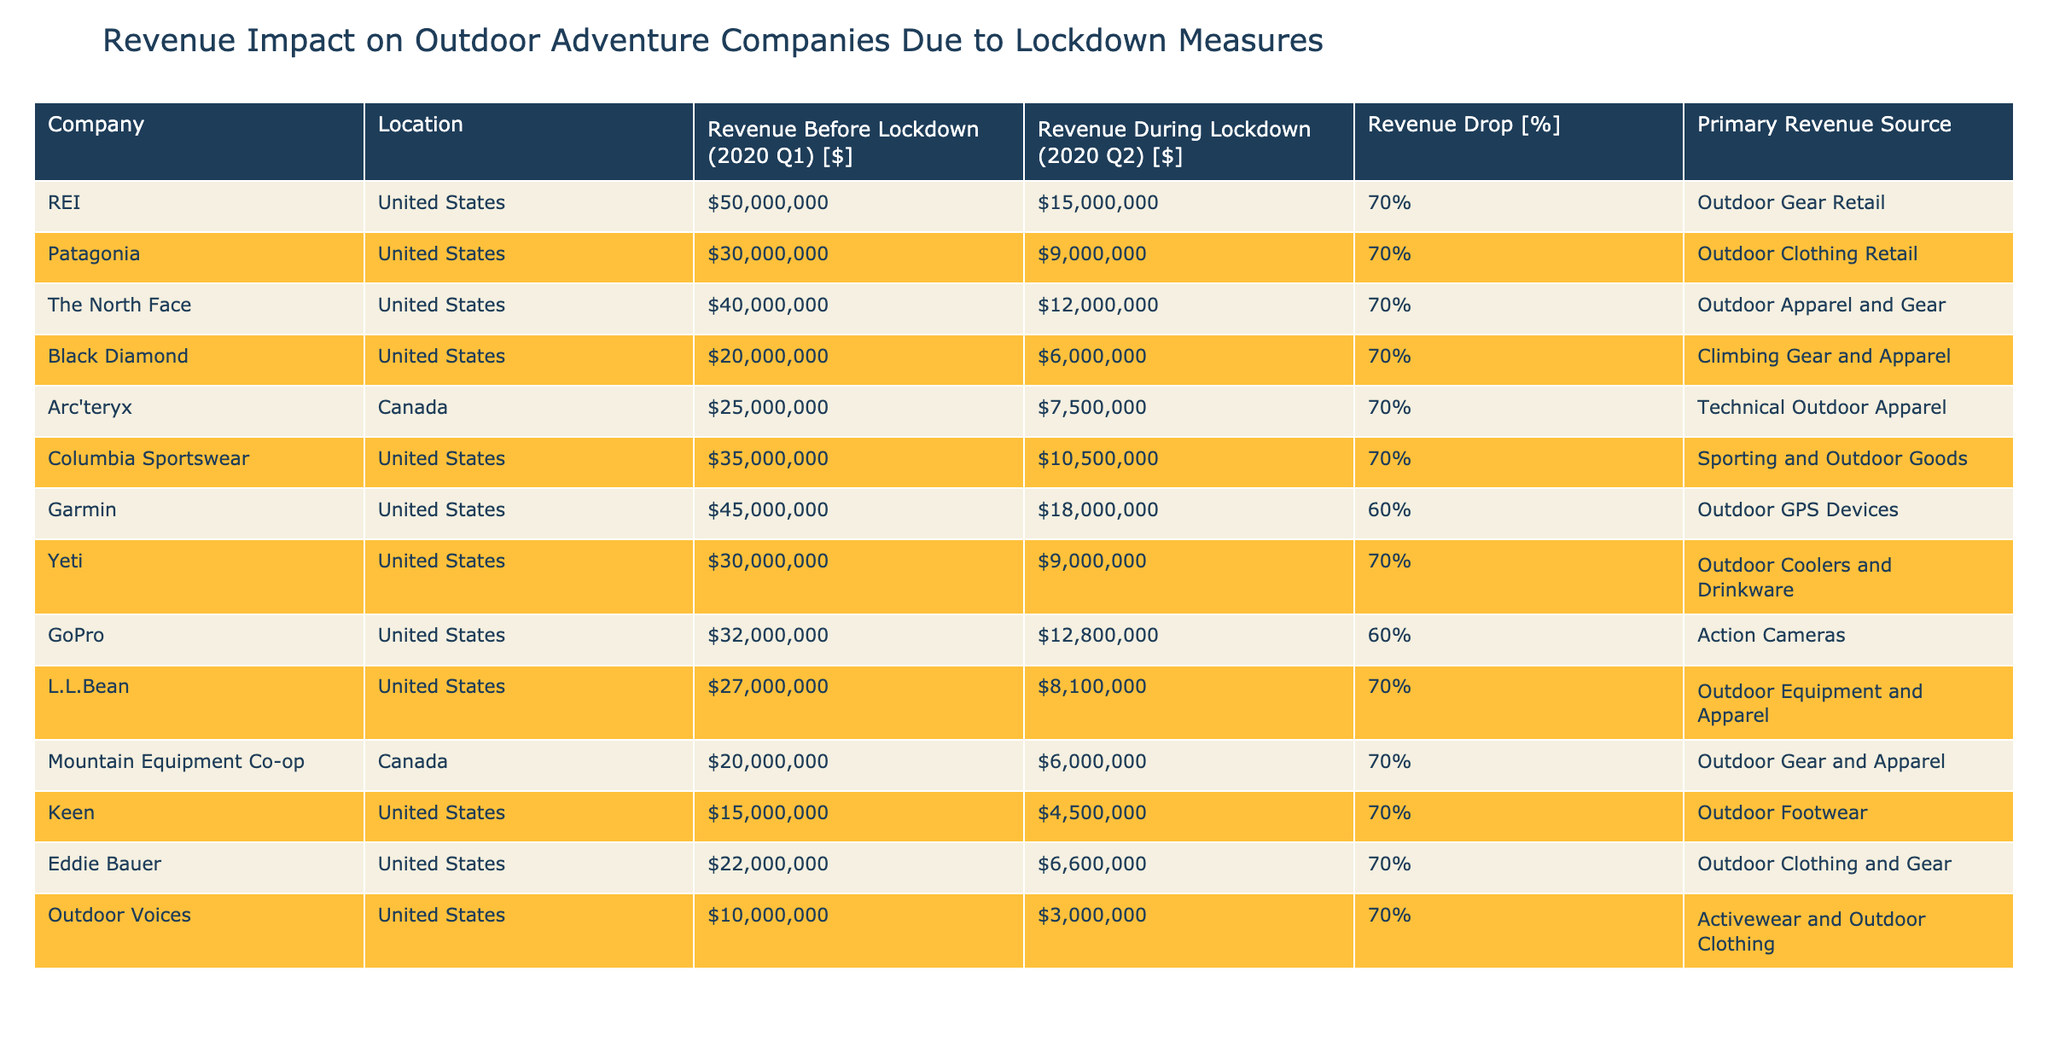What was the revenue of REI before the lockdown? The revenue of REI before the lockdown was listed in the table under the column "Revenue Before Lockdown (2020 Q1) [$]", which shows $50,000,000.
Answer: $50,000,000 What was the primary revenue source for Yeti? In the table, Yeti's primary revenue source is stated in the column "Primary Revenue Source", which indicates that it is "Outdoor Coolers and Drinkware".
Answer: Outdoor Coolers and Drinkware Which company had the smallest revenue drop percentage? By examining the column "Revenue Drop [%]", Garmin had the smallest revenue drop percentage at 60%, while all other companies listed had a drop of 70%.
Answer: Garmin at 60% What is the total revenue during lockdown for all companies? First, we extract the revenue during lockdown from each company: $15,000,000 (REI) + $9,000,000 (Patagonia) + $12,000,000 (The North Face) + $6,000,000 (Black Diamond) + $7,500,000 (Arc'teryx) + $10,500,000 (Columbia Sportswear) + $18,000,000 (Garmin) + $9,000,000 (Yeti) + $12,800,000 (GoPro) + $8,100,000 (L.L.Bean) + $6,000,000 (Mountain Equipment Co-op) + $4,500,000 (Keen) + $6,600,000 (Eddie Bauer) + $3,000,000 (Outdoor Voices). This sums up to $94,500,000.
Answer: $94,500,000 Did any company report a revenue during lockdown of more than $18,000,000? Looking at the "Revenue During Lockdown (2020 Q2) [$]" column, only Garmin reports $18,000,000, while all other companies reported lower amounts. Therefore, no company reported more than that.
Answer: No 